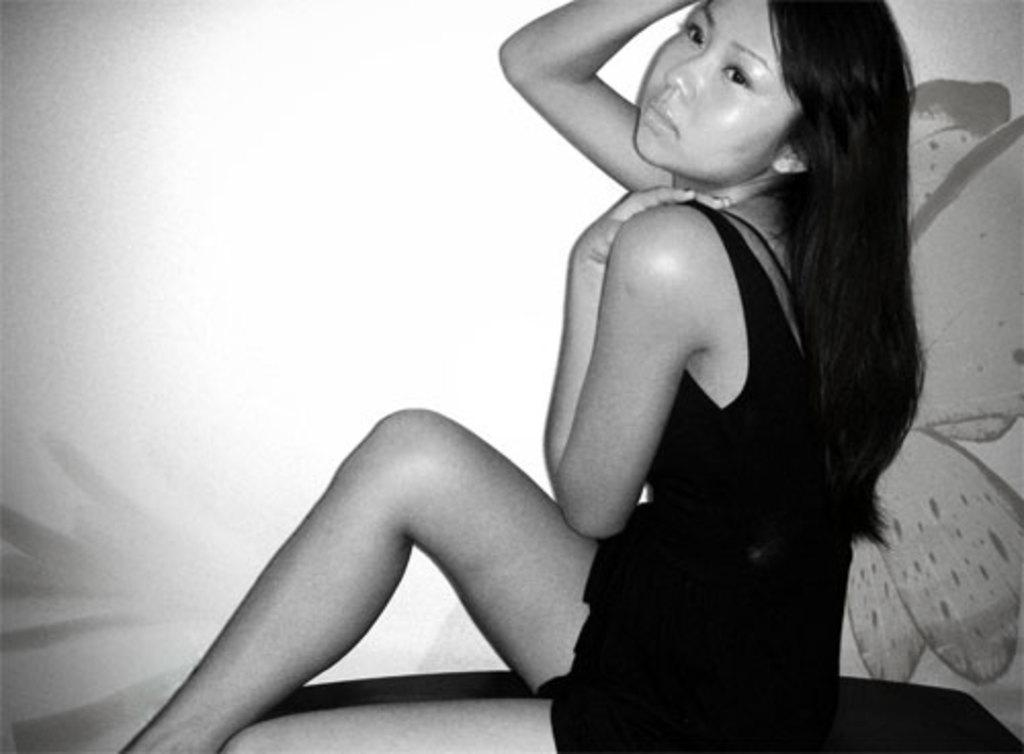Who is the main subject in the image? There is a woman in the image. What is the woman wearing? The woman is wearing a black dress. What is the woman doing in the image? The woman is sitting. What can be seen in the background or as part of the setting in the image? There is a painting of a butterfly in the image. How does the woman compare to the copper statue in the image? There is no copper statue present in the image, so a comparison cannot be made. 